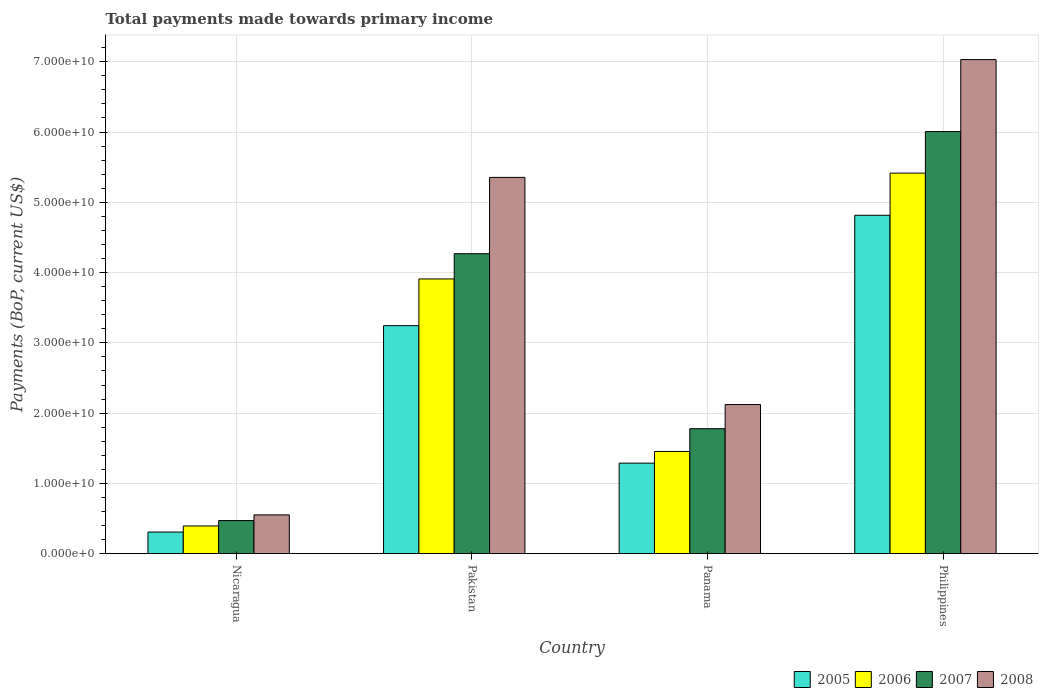How many different coloured bars are there?
Make the answer very short. 4. Are the number of bars per tick equal to the number of legend labels?
Your answer should be very brief. Yes. Are the number of bars on each tick of the X-axis equal?
Give a very brief answer. Yes. How many bars are there on the 4th tick from the left?
Keep it short and to the point. 4. How many bars are there on the 2nd tick from the right?
Your answer should be very brief. 4. What is the label of the 3rd group of bars from the left?
Offer a terse response. Panama. In how many cases, is the number of bars for a given country not equal to the number of legend labels?
Your answer should be very brief. 0. What is the total payments made towards primary income in 2007 in Nicaragua?
Keep it short and to the point. 4.71e+09. Across all countries, what is the maximum total payments made towards primary income in 2005?
Your answer should be very brief. 4.82e+1. Across all countries, what is the minimum total payments made towards primary income in 2006?
Make the answer very short. 3.94e+09. In which country was the total payments made towards primary income in 2008 minimum?
Offer a very short reply. Nicaragua. What is the total total payments made towards primary income in 2008 in the graph?
Give a very brief answer. 1.51e+11. What is the difference between the total payments made towards primary income in 2008 in Nicaragua and that in Pakistan?
Provide a succinct answer. -4.80e+1. What is the difference between the total payments made towards primary income in 2007 in Philippines and the total payments made towards primary income in 2005 in Nicaragua?
Your answer should be very brief. 5.70e+1. What is the average total payments made towards primary income in 2007 per country?
Offer a very short reply. 3.13e+1. What is the difference between the total payments made towards primary income of/in 2005 and total payments made towards primary income of/in 2006 in Philippines?
Give a very brief answer. -6.00e+09. What is the ratio of the total payments made towards primary income in 2007 in Nicaragua to that in Panama?
Your response must be concise. 0.26. Is the difference between the total payments made towards primary income in 2005 in Nicaragua and Pakistan greater than the difference between the total payments made towards primary income in 2006 in Nicaragua and Pakistan?
Keep it short and to the point. Yes. What is the difference between the highest and the second highest total payments made towards primary income in 2005?
Give a very brief answer. -1.57e+1. What is the difference between the highest and the lowest total payments made towards primary income in 2007?
Keep it short and to the point. 5.54e+1. Is the sum of the total payments made towards primary income in 2007 in Panama and Philippines greater than the maximum total payments made towards primary income in 2005 across all countries?
Keep it short and to the point. Yes. What does the 1st bar from the left in Pakistan represents?
Keep it short and to the point. 2005. How many bars are there?
Give a very brief answer. 16. How many countries are there in the graph?
Ensure brevity in your answer.  4. Are the values on the major ticks of Y-axis written in scientific E-notation?
Give a very brief answer. Yes. What is the title of the graph?
Keep it short and to the point. Total payments made towards primary income. Does "1996" appear as one of the legend labels in the graph?
Ensure brevity in your answer.  No. What is the label or title of the Y-axis?
Ensure brevity in your answer.  Payments (BoP, current US$). What is the Payments (BoP, current US$) of 2005 in Nicaragua?
Your response must be concise. 3.07e+09. What is the Payments (BoP, current US$) in 2006 in Nicaragua?
Keep it short and to the point. 3.94e+09. What is the Payments (BoP, current US$) of 2007 in Nicaragua?
Offer a very short reply. 4.71e+09. What is the Payments (BoP, current US$) in 2008 in Nicaragua?
Provide a short and direct response. 5.52e+09. What is the Payments (BoP, current US$) in 2005 in Pakistan?
Offer a terse response. 3.24e+1. What is the Payments (BoP, current US$) in 2006 in Pakistan?
Provide a succinct answer. 3.91e+1. What is the Payments (BoP, current US$) of 2007 in Pakistan?
Your answer should be compact. 4.27e+1. What is the Payments (BoP, current US$) of 2008 in Pakistan?
Make the answer very short. 5.35e+1. What is the Payments (BoP, current US$) in 2005 in Panama?
Provide a short and direct response. 1.29e+1. What is the Payments (BoP, current US$) of 2006 in Panama?
Provide a succinct answer. 1.45e+1. What is the Payments (BoP, current US$) in 2007 in Panama?
Your answer should be compact. 1.78e+1. What is the Payments (BoP, current US$) of 2008 in Panama?
Your answer should be very brief. 2.12e+1. What is the Payments (BoP, current US$) in 2005 in Philippines?
Ensure brevity in your answer.  4.82e+1. What is the Payments (BoP, current US$) of 2006 in Philippines?
Offer a terse response. 5.42e+1. What is the Payments (BoP, current US$) of 2007 in Philippines?
Your answer should be compact. 6.01e+1. What is the Payments (BoP, current US$) of 2008 in Philippines?
Ensure brevity in your answer.  7.03e+1. Across all countries, what is the maximum Payments (BoP, current US$) in 2005?
Provide a short and direct response. 4.82e+1. Across all countries, what is the maximum Payments (BoP, current US$) in 2006?
Make the answer very short. 5.42e+1. Across all countries, what is the maximum Payments (BoP, current US$) in 2007?
Offer a terse response. 6.01e+1. Across all countries, what is the maximum Payments (BoP, current US$) of 2008?
Provide a short and direct response. 7.03e+1. Across all countries, what is the minimum Payments (BoP, current US$) of 2005?
Ensure brevity in your answer.  3.07e+09. Across all countries, what is the minimum Payments (BoP, current US$) in 2006?
Your response must be concise. 3.94e+09. Across all countries, what is the minimum Payments (BoP, current US$) in 2007?
Ensure brevity in your answer.  4.71e+09. Across all countries, what is the minimum Payments (BoP, current US$) of 2008?
Provide a short and direct response. 5.52e+09. What is the total Payments (BoP, current US$) in 2005 in the graph?
Provide a short and direct response. 9.66e+1. What is the total Payments (BoP, current US$) of 2006 in the graph?
Your answer should be compact. 1.12e+11. What is the total Payments (BoP, current US$) of 2007 in the graph?
Provide a short and direct response. 1.25e+11. What is the total Payments (BoP, current US$) in 2008 in the graph?
Offer a very short reply. 1.51e+11. What is the difference between the Payments (BoP, current US$) in 2005 in Nicaragua and that in Pakistan?
Your response must be concise. -2.94e+1. What is the difference between the Payments (BoP, current US$) of 2006 in Nicaragua and that in Pakistan?
Offer a terse response. -3.52e+1. What is the difference between the Payments (BoP, current US$) in 2007 in Nicaragua and that in Pakistan?
Keep it short and to the point. -3.80e+1. What is the difference between the Payments (BoP, current US$) of 2008 in Nicaragua and that in Pakistan?
Your answer should be very brief. -4.80e+1. What is the difference between the Payments (BoP, current US$) in 2005 in Nicaragua and that in Panama?
Make the answer very short. -9.81e+09. What is the difference between the Payments (BoP, current US$) in 2006 in Nicaragua and that in Panama?
Your answer should be very brief. -1.06e+1. What is the difference between the Payments (BoP, current US$) of 2007 in Nicaragua and that in Panama?
Give a very brief answer. -1.31e+1. What is the difference between the Payments (BoP, current US$) in 2008 in Nicaragua and that in Panama?
Keep it short and to the point. -1.57e+1. What is the difference between the Payments (BoP, current US$) of 2005 in Nicaragua and that in Philippines?
Your answer should be very brief. -4.51e+1. What is the difference between the Payments (BoP, current US$) of 2006 in Nicaragua and that in Philippines?
Your answer should be very brief. -5.02e+1. What is the difference between the Payments (BoP, current US$) of 2007 in Nicaragua and that in Philippines?
Your response must be concise. -5.54e+1. What is the difference between the Payments (BoP, current US$) in 2008 in Nicaragua and that in Philippines?
Give a very brief answer. -6.48e+1. What is the difference between the Payments (BoP, current US$) in 2005 in Pakistan and that in Panama?
Your answer should be very brief. 1.96e+1. What is the difference between the Payments (BoP, current US$) of 2006 in Pakistan and that in Panama?
Your response must be concise. 2.45e+1. What is the difference between the Payments (BoP, current US$) in 2007 in Pakistan and that in Panama?
Keep it short and to the point. 2.49e+1. What is the difference between the Payments (BoP, current US$) in 2008 in Pakistan and that in Panama?
Provide a short and direct response. 3.23e+1. What is the difference between the Payments (BoP, current US$) of 2005 in Pakistan and that in Philippines?
Keep it short and to the point. -1.57e+1. What is the difference between the Payments (BoP, current US$) of 2006 in Pakistan and that in Philippines?
Ensure brevity in your answer.  -1.51e+1. What is the difference between the Payments (BoP, current US$) of 2007 in Pakistan and that in Philippines?
Make the answer very short. -1.74e+1. What is the difference between the Payments (BoP, current US$) of 2008 in Pakistan and that in Philippines?
Provide a short and direct response. -1.68e+1. What is the difference between the Payments (BoP, current US$) of 2005 in Panama and that in Philippines?
Your response must be concise. -3.53e+1. What is the difference between the Payments (BoP, current US$) in 2006 in Panama and that in Philippines?
Ensure brevity in your answer.  -3.96e+1. What is the difference between the Payments (BoP, current US$) of 2007 in Panama and that in Philippines?
Ensure brevity in your answer.  -4.23e+1. What is the difference between the Payments (BoP, current US$) in 2008 in Panama and that in Philippines?
Your answer should be very brief. -4.91e+1. What is the difference between the Payments (BoP, current US$) of 2005 in Nicaragua and the Payments (BoP, current US$) of 2006 in Pakistan?
Make the answer very short. -3.60e+1. What is the difference between the Payments (BoP, current US$) in 2005 in Nicaragua and the Payments (BoP, current US$) in 2007 in Pakistan?
Provide a short and direct response. -3.96e+1. What is the difference between the Payments (BoP, current US$) of 2005 in Nicaragua and the Payments (BoP, current US$) of 2008 in Pakistan?
Ensure brevity in your answer.  -5.05e+1. What is the difference between the Payments (BoP, current US$) of 2006 in Nicaragua and the Payments (BoP, current US$) of 2007 in Pakistan?
Provide a short and direct response. -3.87e+1. What is the difference between the Payments (BoP, current US$) of 2006 in Nicaragua and the Payments (BoP, current US$) of 2008 in Pakistan?
Provide a short and direct response. -4.96e+1. What is the difference between the Payments (BoP, current US$) in 2007 in Nicaragua and the Payments (BoP, current US$) in 2008 in Pakistan?
Provide a succinct answer. -4.88e+1. What is the difference between the Payments (BoP, current US$) of 2005 in Nicaragua and the Payments (BoP, current US$) of 2006 in Panama?
Keep it short and to the point. -1.15e+1. What is the difference between the Payments (BoP, current US$) of 2005 in Nicaragua and the Payments (BoP, current US$) of 2007 in Panama?
Offer a terse response. -1.47e+1. What is the difference between the Payments (BoP, current US$) of 2005 in Nicaragua and the Payments (BoP, current US$) of 2008 in Panama?
Give a very brief answer. -1.81e+1. What is the difference between the Payments (BoP, current US$) of 2006 in Nicaragua and the Payments (BoP, current US$) of 2007 in Panama?
Offer a terse response. -1.38e+1. What is the difference between the Payments (BoP, current US$) in 2006 in Nicaragua and the Payments (BoP, current US$) in 2008 in Panama?
Offer a very short reply. -1.73e+1. What is the difference between the Payments (BoP, current US$) in 2007 in Nicaragua and the Payments (BoP, current US$) in 2008 in Panama?
Keep it short and to the point. -1.65e+1. What is the difference between the Payments (BoP, current US$) of 2005 in Nicaragua and the Payments (BoP, current US$) of 2006 in Philippines?
Offer a terse response. -5.11e+1. What is the difference between the Payments (BoP, current US$) of 2005 in Nicaragua and the Payments (BoP, current US$) of 2007 in Philippines?
Your answer should be very brief. -5.70e+1. What is the difference between the Payments (BoP, current US$) of 2005 in Nicaragua and the Payments (BoP, current US$) of 2008 in Philippines?
Make the answer very short. -6.72e+1. What is the difference between the Payments (BoP, current US$) of 2006 in Nicaragua and the Payments (BoP, current US$) of 2007 in Philippines?
Offer a very short reply. -5.61e+1. What is the difference between the Payments (BoP, current US$) of 2006 in Nicaragua and the Payments (BoP, current US$) of 2008 in Philippines?
Offer a very short reply. -6.64e+1. What is the difference between the Payments (BoP, current US$) of 2007 in Nicaragua and the Payments (BoP, current US$) of 2008 in Philippines?
Provide a short and direct response. -6.56e+1. What is the difference between the Payments (BoP, current US$) in 2005 in Pakistan and the Payments (BoP, current US$) in 2006 in Panama?
Your answer should be very brief. 1.79e+1. What is the difference between the Payments (BoP, current US$) of 2005 in Pakistan and the Payments (BoP, current US$) of 2007 in Panama?
Keep it short and to the point. 1.47e+1. What is the difference between the Payments (BoP, current US$) in 2005 in Pakistan and the Payments (BoP, current US$) in 2008 in Panama?
Make the answer very short. 1.12e+1. What is the difference between the Payments (BoP, current US$) of 2006 in Pakistan and the Payments (BoP, current US$) of 2007 in Panama?
Your answer should be very brief. 2.13e+1. What is the difference between the Payments (BoP, current US$) in 2006 in Pakistan and the Payments (BoP, current US$) in 2008 in Panama?
Provide a short and direct response. 1.79e+1. What is the difference between the Payments (BoP, current US$) of 2007 in Pakistan and the Payments (BoP, current US$) of 2008 in Panama?
Make the answer very short. 2.15e+1. What is the difference between the Payments (BoP, current US$) in 2005 in Pakistan and the Payments (BoP, current US$) in 2006 in Philippines?
Your answer should be compact. -2.17e+1. What is the difference between the Payments (BoP, current US$) of 2005 in Pakistan and the Payments (BoP, current US$) of 2007 in Philippines?
Ensure brevity in your answer.  -2.76e+1. What is the difference between the Payments (BoP, current US$) of 2005 in Pakistan and the Payments (BoP, current US$) of 2008 in Philippines?
Offer a very short reply. -3.79e+1. What is the difference between the Payments (BoP, current US$) of 2006 in Pakistan and the Payments (BoP, current US$) of 2007 in Philippines?
Offer a very short reply. -2.10e+1. What is the difference between the Payments (BoP, current US$) of 2006 in Pakistan and the Payments (BoP, current US$) of 2008 in Philippines?
Your answer should be compact. -3.12e+1. What is the difference between the Payments (BoP, current US$) of 2007 in Pakistan and the Payments (BoP, current US$) of 2008 in Philippines?
Provide a short and direct response. -2.76e+1. What is the difference between the Payments (BoP, current US$) of 2005 in Panama and the Payments (BoP, current US$) of 2006 in Philippines?
Your answer should be very brief. -4.13e+1. What is the difference between the Payments (BoP, current US$) of 2005 in Panama and the Payments (BoP, current US$) of 2007 in Philippines?
Provide a short and direct response. -4.72e+1. What is the difference between the Payments (BoP, current US$) of 2005 in Panama and the Payments (BoP, current US$) of 2008 in Philippines?
Keep it short and to the point. -5.74e+1. What is the difference between the Payments (BoP, current US$) in 2006 in Panama and the Payments (BoP, current US$) in 2007 in Philippines?
Offer a very short reply. -4.55e+1. What is the difference between the Payments (BoP, current US$) in 2006 in Panama and the Payments (BoP, current US$) in 2008 in Philippines?
Provide a short and direct response. -5.58e+1. What is the difference between the Payments (BoP, current US$) of 2007 in Panama and the Payments (BoP, current US$) of 2008 in Philippines?
Ensure brevity in your answer.  -5.25e+1. What is the average Payments (BoP, current US$) in 2005 per country?
Ensure brevity in your answer.  2.41e+1. What is the average Payments (BoP, current US$) of 2006 per country?
Your answer should be very brief. 2.79e+1. What is the average Payments (BoP, current US$) of 2007 per country?
Offer a very short reply. 3.13e+1. What is the average Payments (BoP, current US$) of 2008 per country?
Offer a terse response. 3.76e+1. What is the difference between the Payments (BoP, current US$) in 2005 and Payments (BoP, current US$) in 2006 in Nicaragua?
Offer a terse response. -8.67e+08. What is the difference between the Payments (BoP, current US$) of 2005 and Payments (BoP, current US$) of 2007 in Nicaragua?
Offer a terse response. -1.64e+09. What is the difference between the Payments (BoP, current US$) of 2005 and Payments (BoP, current US$) of 2008 in Nicaragua?
Make the answer very short. -2.44e+09. What is the difference between the Payments (BoP, current US$) of 2006 and Payments (BoP, current US$) of 2007 in Nicaragua?
Ensure brevity in your answer.  -7.70e+08. What is the difference between the Payments (BoP, current US$) of 2006 and Payments (BoP, current US$) of 2008 in Nicaragua?
Offer a very short reply. -1.58e+09. What is the difference between the Payments (BoP, current US$) in 2007 and Payments (BoP, current US$) in 2008 in Nicaragua?
Ensure brevity in your answer.  -8.07e+08. What is the difference between the Payments (BoP, current US$) in 2005 and Payments (BoP, current US$) in 2006 in Pakistan?
Ensure brevity in your answer.  -6.65e+09. What is the difference between the Payments (BoP, current US$) of 2005 and Payments (BoP, current US$) of 2007 in Pakistan?
Your response must be concise. -1.02e+1. What is the difference between the Payments (BoP, current US$) of 2005 and Payments (BoP, current US$) of 2008 in Pakistan?
Your answer should be compact. -2.11e+1. What is the difference between the Payments (BoP, current US$) in 2006 and Payments (BoP, current US$) in 2007 in Pakistan?
Your answer should be compact. -3.59e+09. What is the difference between the Payments (BoP, current US$) in 2006 and Payments (BoP, current US$) in 2008 in Pakistan?
Give a very brief answer. -1.45e+1. What is the difference between the Payments (BoP, current US$) in 2007 and Payments (BoP, current US$) in 2008 in Pakistan?
Provide a short and direct response. -1.09e+1. What is the difference between the Payments (BoP, current US$) of 2005 and Payments (BoP, current US$) of 2006 in Panama?
Give a very brief answer. -1.66e+09. What is the difference between the Payments (BoP, current US$) of 2005 and Payments (BoP, current US$) of 2007 in Panama?
Your answer should be compact. -4.90e+09. What is the difference between the Payments (BoP, current US$) in 2005 and Payments (BoP, current US$) in 2008 in Panama?
Provide a short and direct response. -8.33e+09. What is the difference between the Payments (BoP, current US$) of 2006 and Payments (BoP, current US$) of 2007 in Panama?
Your answer should be very brief. -3.24e+09. What is the difference between the Payments (BoP, current US$) of 2006 and Payments (BoP, current US$) of 2008 in Panama?
Your answer should be compact. -6.67e+09. What is the difference between the Payments (BoP, current US$) of 2007 and Payments (BoP, current US$) of 2008 in Panama?
Keep it short and to the point. -3.43e+09. What is the difference between the Payments (BoP, current US$) of 2005 and Payments (BoP, current US$) of 2006 in Philippines?
Ensure brevity in your answer.  -6.00e+09. What is the difference between the Payments (BoP, current US$) of 2005 and Payments (BoP, current US$) of 2007 in Philippines?
Offer a very short reply. -1.19e+1. What is the difference between the Payments (BoP, current US$) of 2005 and Payments (BoP, current US$) of 2008 in Philippines?
Your response must be concise. -2.22e+1. What is the difference between the Payments (BoP, current US$) of 2006 and Payments (BoP, current US$) of 2007 in Philippines?
Offer a very short reply. -5.92e+09. What is the difference between the Payments (BoP, current US$) of 2006 and Payments (BoP, current US$) of 2008 in Philippines?
Make the answer very short. -1.62e+1. What is the difference between the Payments (BoP, current US$) of 2007 and Payments (BoP, current US$) of 2008 in Philippines?
Your response must be concise. -1.02e+1. What is the ratio of the Payments (BoP, current US$) in 2005 in Nicaragua to that in Pakistan?
Your answer should be compact. 0.09. What is the ratio of the Payments (BoP, current US$) of 2006 in Nicaragua to that in Pakistan?
Ensure brevity in your answer.  0.1. What is the ratio of the Payments (BoP, current US$) in 2007 in Nicaragua to that in Pakistan?
Keep it short and to the point. 0.11. What is the ratio of the Payments (BoP, current US$) of 2008 in Nicaragua to that in Pakistan?
Your response must be concise. 0.1. What is the ratio of the Payments (BoP, current US$) in 2005 in Nicaragua to that in Panama?
Keep it short and to the point. 0.24. What is the ratio of the Payments (BoP, current US$) in 2006 in Nicaragua to that in Panama?
Make the answer very short. 0.27. What is the ratio of the Payments (BoP, current US$) in 2007 in Nicaragua to that in Panama?
Your answer should be very brief. 0.27. What is the ratio of the Payments (BoP, current US$) in 2008 in Nicaragua to that in Panama?
Provide a succinct answer. 0.26. What is the ratio of the Payments (BoP, current US$) of 2005 in Nicaragua to that in Philippines?
Your answer should be compact. 0.06. What is the ratio of the Payments (BoP, current US$) of 2006 in Nicaragua to that in Philippines?
Your response must be concise. 0.07. What is the ratio of the Payments (BoP, current US$) in 2007 in Nicaragua to that in Philippines?
Make the answer very short. 0.08. What is the ratio of the Payments (BoP, current US$) in 2008 in Nicaragua to that in Philippines?
Ensure brevity in your answer.  0.08. What is the ratio of the Payments (BoP, current US$) in 2005 in Pakistan to that in Panama?
Give a very brief answer. 2.52. What is the ratio of the Payments (BoP, current US$) of 2006 in Pakistan to that in Panama?
Give a very brief answer. 2.69. What is the ratio of the Payments (BoP, current US$) in 2007 in Pakistan to that in Panama?
Your answer should be compact. 2.4. What is the ratio of the Payments (BoP, current US$) in 2008 in Pakistan to that in Panama?
Your answer should be very brief. 2.52. What is the ratio of the Payments (BoP, current US$) of 2005 in Pakistan to that in Philippines?
Offer a very short reply. 0.67. What is the ratio of the Payments (BoP, current US$) of 2006 in Pakistan to that in Philippines?
Provide a succinct answer. 0.72. What is the ratio of the Payments (BoP, current US$) of 2007 in Pakistan to that in Philippines?
Give a very brief answer. 0.71. What is the ratio of the Payments (BoP, current US$) of 2008 in Pakistan to that in Philippines?
Your answer should be compact. 0.76. What is the ratio of the Payments (BoP, current US$) of 2005 in Panama to that in Philippines?
Your response must be concise. 0.27. What is the ratio of the Payments (BoP, current US$) in 2006 in Panama to that in Philippines?
Provide a short and direct response. 0.27. What is the ratio of the Payments (BoP, current US$) of 2007 in Panama to that in Philippines?
Give a very brief answer. 0.3. What is the ratio of the Payments (BoP, current US$) of 2008 in Panama to that in Philippines?
Provide a succinct answer. 0.3. What is the difference between the highest and the second highest Payments (BoP, current US$) in 2005?
Ensure brevity in your answer.  1.57e+1. What is the difference between the highest and the second highest Payments (BoP, current US$) in 2006?
Offer a very short reply. 1.51e+1. What is the difference between the highest and the second highest Payments (BoP, current US$) of 2007?
Your answer should be very brief. 1.74e+1. What is the difference between the highest and the second highest Payments (BoP, current US$) of 2008?
Give a very brief answer. 1.68e+1. What is the difference between the highest and the lowest Payments (BoP, current US$) in 2005?
Offer a very short reply. 4.51e+1. What is the difference between the highest and the lowest Payments (BoP, current US$) of 2006?
Your answer should be very brief. 5.02e+1. What is the difference between the highest and the lowest Payments (BoP, current US$) in 2007?
Your response must be concise. 5.54e+1. What is the difference between the highest and the lowest Payments (BoP, current US$) in 2008?
Keep it short and to the point. 6.48e+1. 